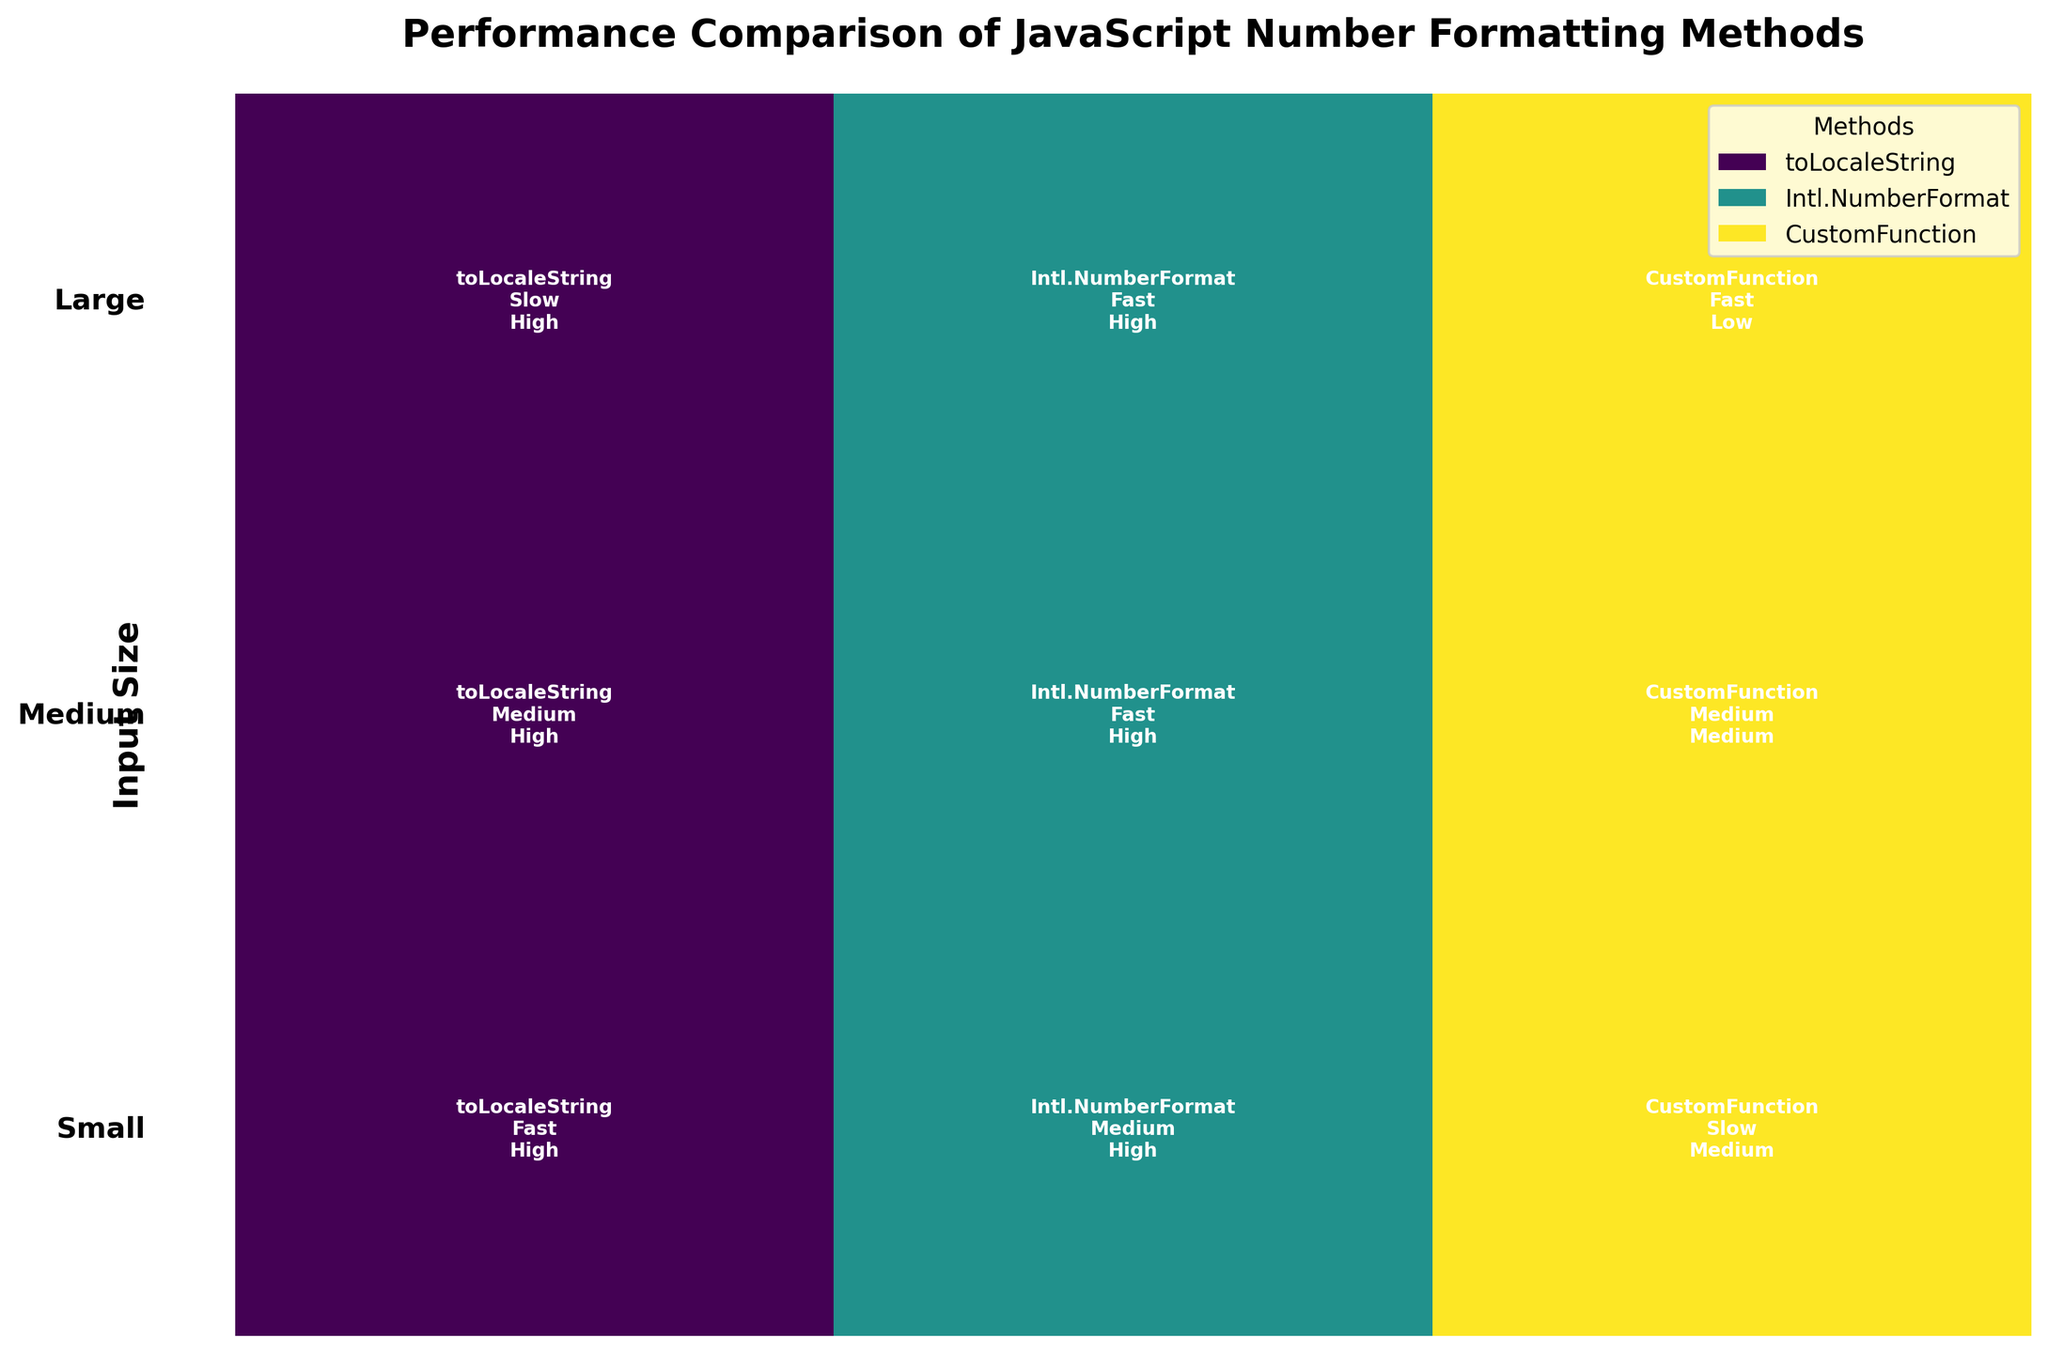What is the title of the figure? The title of the figure is usually displayed at the top and holds the main theme or message of the figure. Here, it's highlighting performance comparisons.
Answer: Performance Comparison of JavaScript Number Formatting Methods Which method has the highest accuracy for large input sizes? To find this, look at the section for "Large" input sizes. Observe the accuracy annotations for each method. Here, 'toLocaleString' and 'Intl.NumberFormat' have 'High' accuracy whereas 'CustomFunction' has 'Low'.
Answer: toLocaleString and Intl.NumberFormat What color is used to represent the 'Intl.NumberFormat' method? The colors are assigned to each method and are shown in the legend. The color associated with 'Intl.NumberFormat' can be seen in the corresponding legend item or annotated areas in the figure.
Answer: Check the legend, typically a shade of green Which method performs the fastest for medium input sizes? Look at the "Medium" row and identify the performance annotations. 'Intl.NumberFormat' is marked as 'Fast' in this section.
Answer: Intl.NumberFormat Which input size category has the most variance in performance among the methods? Compare the performance labels (Fast, Medium, Slow) across methods within each input size category (Small, Medium, Large). You need to see where the differences are most varied.
Answer: Small (Fast, Medium, Slow) How many methods are compared in the figure? This can be determined by counting the number of unique items in the legend, as each represents a distinct method.
Answer: Three methods Which method is the slowest for small input sizes? By examining the "Small" input size row, check for the 'Slow' performance label. 'CustomFunction' is marked as 'Slow' here.
Answer: CustomFunction For which input size does 'toLocaleString' method show a medium performance? Scan the performance annotations for 'toLocaleString' across input sizes. It is 'Medium' for 'Medium' input sizes.
Answer: Medium What is the range of accuracy levels presented in the figure? Observe the annotations on the figure describing accuracy, noting the different terms used. The figure shows levels such as High, Medium, and Low.
Answer: High, Medium, Low 